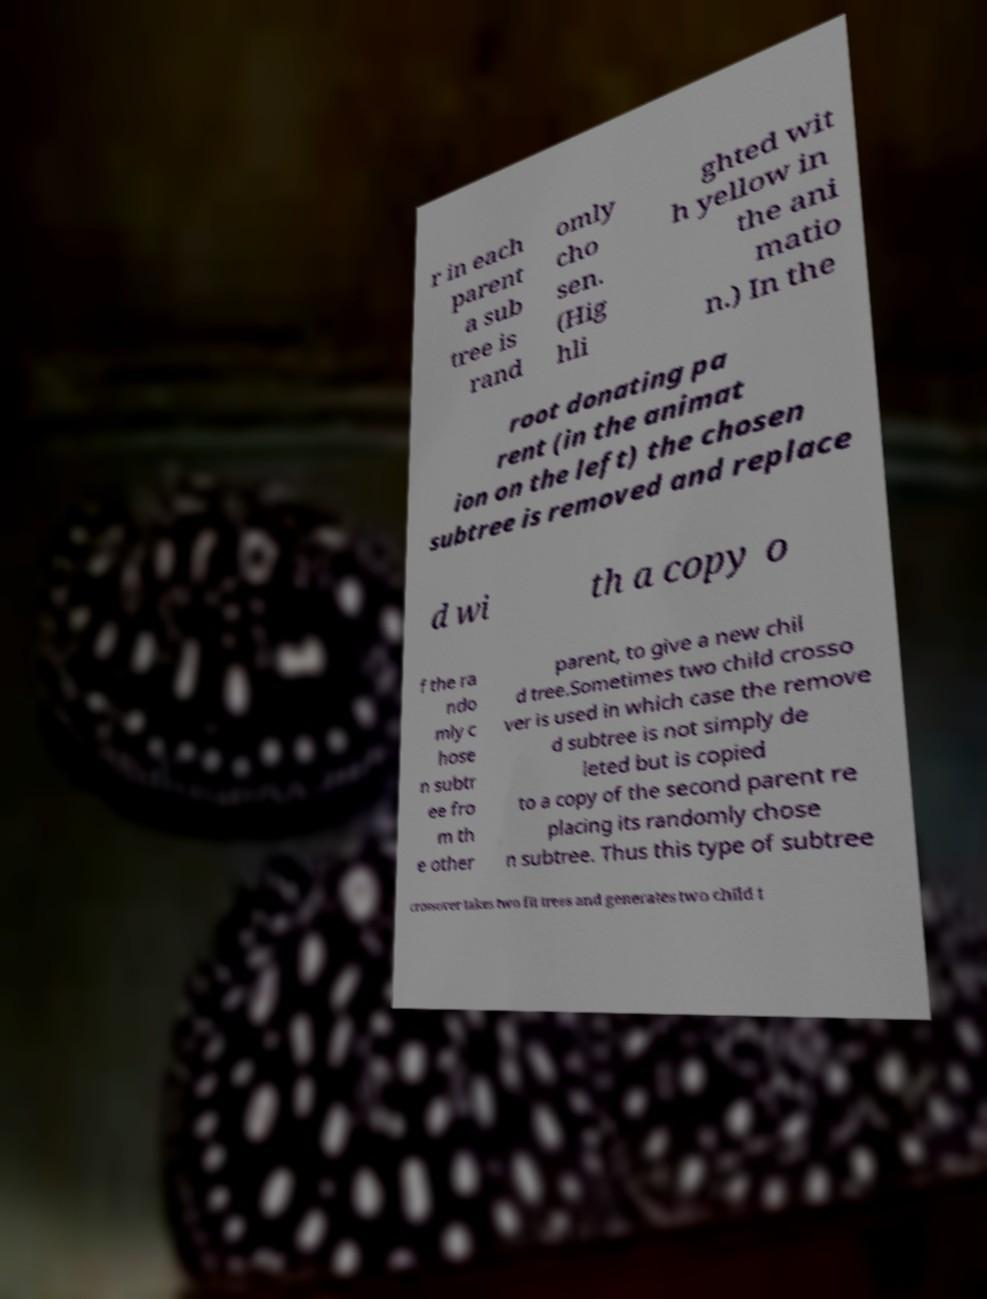Please identify and transcribe the text found in this image. r in each parent a sub tree is rand omly cho sen. (Hig hli ghted wit h yellow in the ani matio n.) In the root donating pa rent (in the animat ion on the left) the chosen subtree is removed and replace d wi th a copy o f the ra ndo mly c hose n subtr ee fro m th e other parent, to give a new chil d tree.Sometimes two child crosso ver is used in which case the remove d subtree is not simply de leted but is copied to a copy of the second parent re placing its randomly chose n subtree. Thus this type of subtree crossover takes two fit trees and generates two child t 